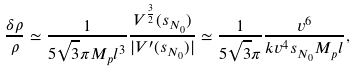<formula> <loc_0><loc_0><loc_500><loc_500>\frac { \delta \rho } { \rho } \simeq \frac { 1 } { 5 \sqrt { 3 } \pi M _ { p } l ^ { 3 } } \frac { V ^ { \frac { 3 } { 2 } } ( s _ { N _ { 0 } } ) } { | V ^ { \prime } ( s _ { N _ { 0 } } ) | } \simeq \frac { 1 } { 5 \sqrt { 3 } \pi } \frac { v ^ { 6 } } { k v ^ { 4 } s _ { N _ { 0 } } M _ { p } l } ,</formula> 